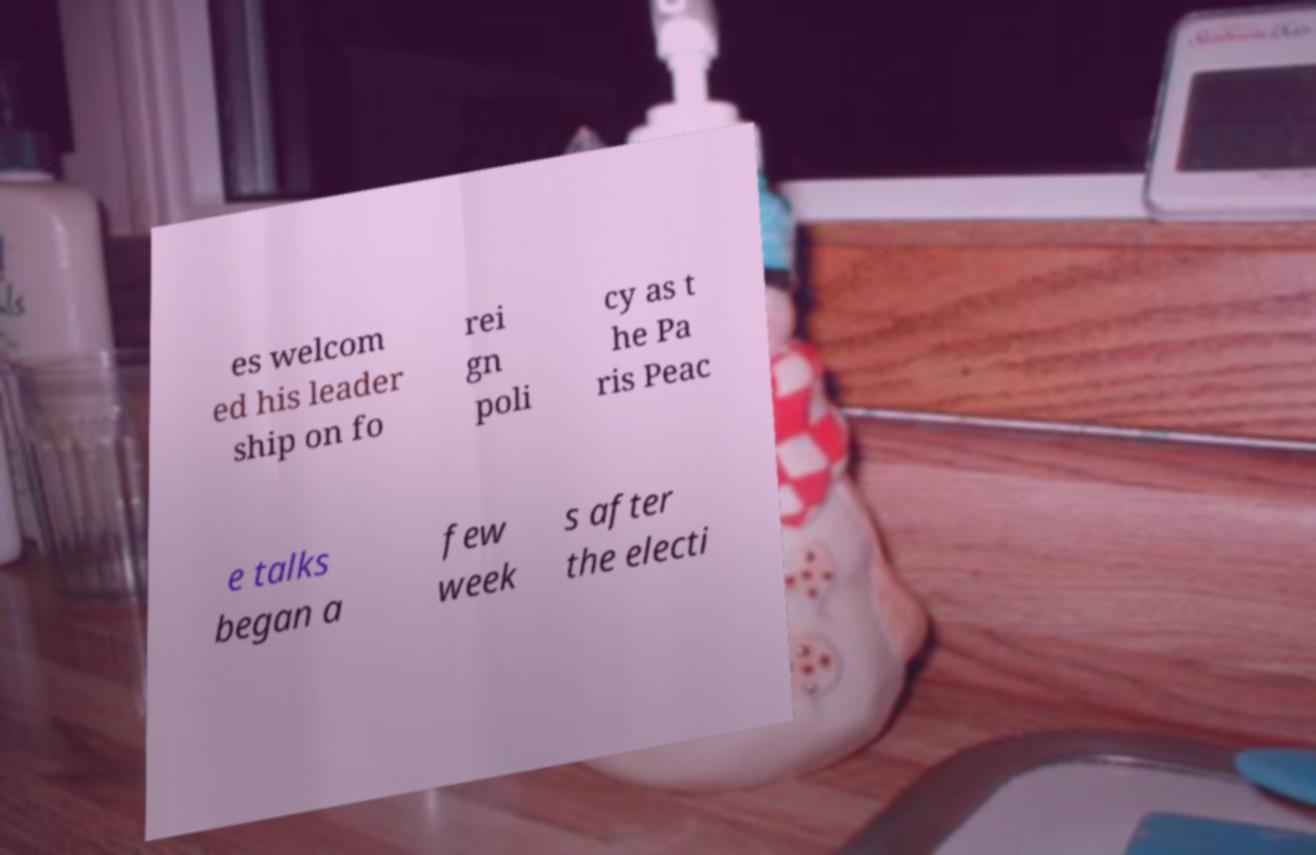Please identify and transcribe the text found in this image. es welcom ed his leader ship on fo rei gn poli cy as t he Pa ris Peac e talks began a few week s after the electi 